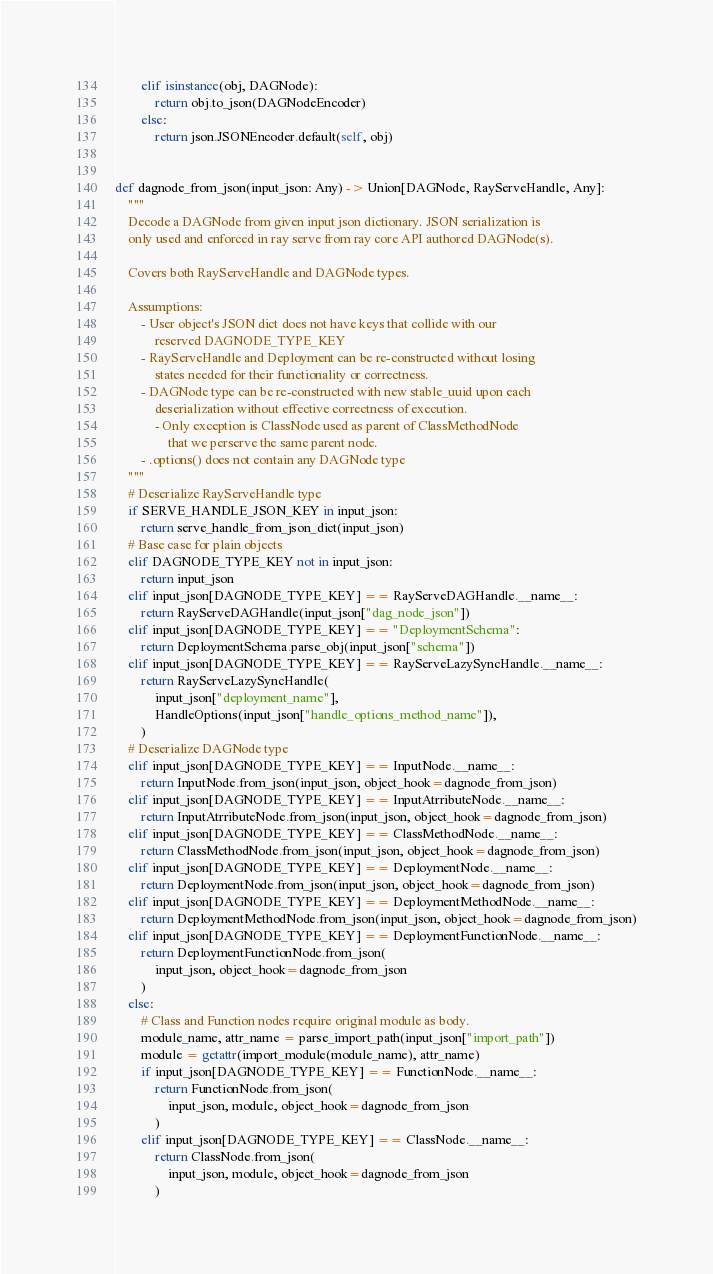Convert code to text. <code><loc_0><loc_0><loc_500><loc_500><_Python_>        elif isinstance(obj, DAGNode):
            return obj.to_json(DAGNodeEncoder)
        else:
            return json.JSONEncoder.default(self, obj)


def dagnode_from_json(input_json: Any) -> Union[DAGNode, RayServeHandle, Any]:
    """
    Decode a DAGNode from given input json dictionary. JSON serialization is
    only used and enforced in ray serve from ray core API authored DAGNode(s).

    Covers both RayServeHandle and DAGNode types.

    Assumptions:
        - User object's JSON dict does not have keys that collide with our
            reserved DAGNODE_TYPE_KEY
        - RayServeHandle and Deployment can be re-constructed without losing
            states needed for their functionality or correctness.
        - DAGNode type can be re-constructed with new stable_uuid upon each
            deserialization without effective correctness of execution.
            - Only exception is ClassNode used as parent of ClassMethodNode
                that we perserve the same parent node.
        - .options() does not contain any DAGNode type
    """
    # Deserialize RayServeHandle type
    if SERVE_HANDLE_JSON_KEY in input_json:
        return serve_handle_from_json_dict(input_json)
    # Base case for plain objects
    elif DAGNODE_TYPE_KEY not in input_json:
        return input_json
    elif input_json[DAGNODE_TYPE_KEY] == RayServeDAGHandle.__name__:
        return RayServeDAGHandle(input_json["dag_node_json"])
    elif input_json[DAGNODE_TYPE_KEY] == "DeploymentSchema":
        return DeploymentSchema.parse_obj(input_json["schema"])
    elif input_json[DAGNODE_TYPE_KEY] == RayServeLazySyncHandle.__name__:
        return RayServeLazySyncHandle(
            input_json["deployment_name"],
            HandleOptions(input_json["handle_options_method_name"]),
        )
    # Deserialize DAGNode type
    elif input_json[DAGNODE_TYPE_KEY] == InputNode.__name__:
        return InputNode.from_json(input_json, object_hook=dagnode_from_json)
    elif input_json[DAGNODE_TYPE_KEY] == InputAtrributeNode.__name__:
        return InputAtrributeNode.from_json(input_json, object_hook=dagnode_from_json)
    elif input_json[DAGNODE_TYPE_KEY] == ClassMethodNode.__name__:
        return ClassMethodNode.from_json(input_json, object_hook=dagnode_from_json)
    elif input_json[DAGNODE_TYPE_KEY] == DeploymentNode.__name__:
        return DeploymentNode.from_json(input_json, object_hook=dagnode_from_json)
    elif input_json[DAGNODE_TYPE_KEY] == DeploymentMethodNode.__name__:
        return DeploymentMethodNode.from_json(input_json, object_hook=dagnode_from_json)
    elif input_json[DAGNODE_TYPE_KEY] == DeploymentFunctionNode.__name__:
        return DeploymentFunctionNode.from_json(
            input_json, object_hook=dagnode_from_json
        )
    else:
        # Class and Function nodes require original module as body.
        module_name, attr_name = parse_import_path(input_json["import_path"])
        module = getattr(import_module(module_name), attr_name)
        if input_json[DAGNODE_TYPE_KEY] == FunctionNode.__name__:
            return FunctionNode.from_json(
                input_json, module, object_hook=dagnode_from_json
            )
        elif input_json[DAGNODE_TYPE_KEY] == ClassNode.__name__:
            return ClassNode.from_json(
                input_json, module, object_hook=dagnode_from_json
            )
</code> 